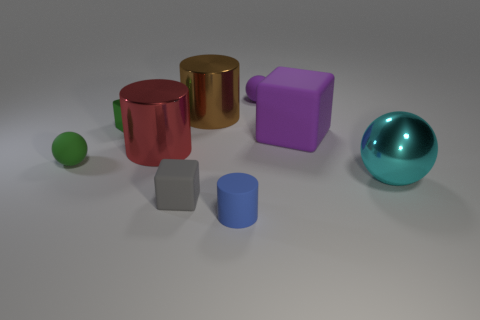Subtract all brown metal cylinders. How many cylinders are left? 2 Subtract all cubes. How many objects are left? 6 Subtract 1 spheres. How many spheres are left? 2 Subtract all gray blocks. Subtract all red cylinders. How many blocks are left? 2 Subtract all yellow matte things. Subtract all blue cylinders. How many objects are left? 8 Add 1 brown shiny cylinders. How many brown shiny cylinders are left? 2 Add 2 big red cylinders. How many big red cylinders exist? 3 Subtract 1 green blocks. How many objects are left? 8 